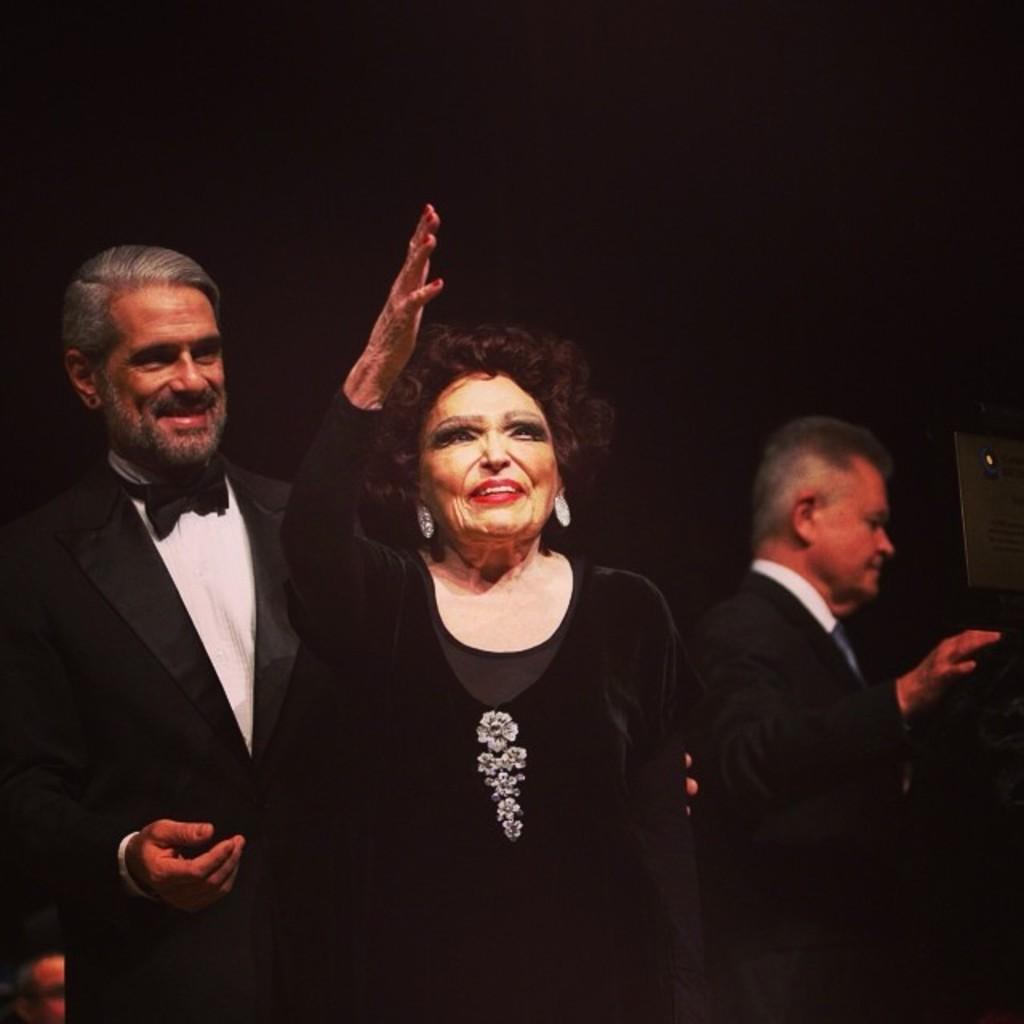What is the main subject of the image? There is a person standing in the center of the image. Are there any other people visible in the image? Yes, there are a few other people behind the person in the center. What can be seen on the right side of the image? There is an object on the right side of the image. What type of grape is being used to express disgust in the image? There is no grape present in the image, nor is there any expression of disgust. 